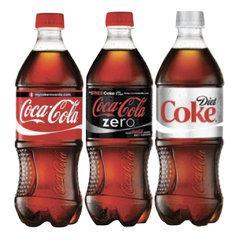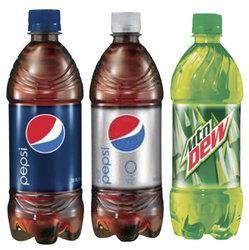The first image is the image on the left, the second image is the image on the right. For the images displayed, is the sentence "Only plastic, filled soda bottles with lids and labels are shown, and the left image features at least one bottle with a semi-hourglass shape, while the right image shows three bottles with different labels." factually correct? Answer yes or no. Yes. The first image is the image on the left, the second image is the image on the right. Evaluate the accuracy of this statement regarding the images: "In the right image, there is a green colored plastic soda bottle". Is it true? Answer yes or no. Yes. 